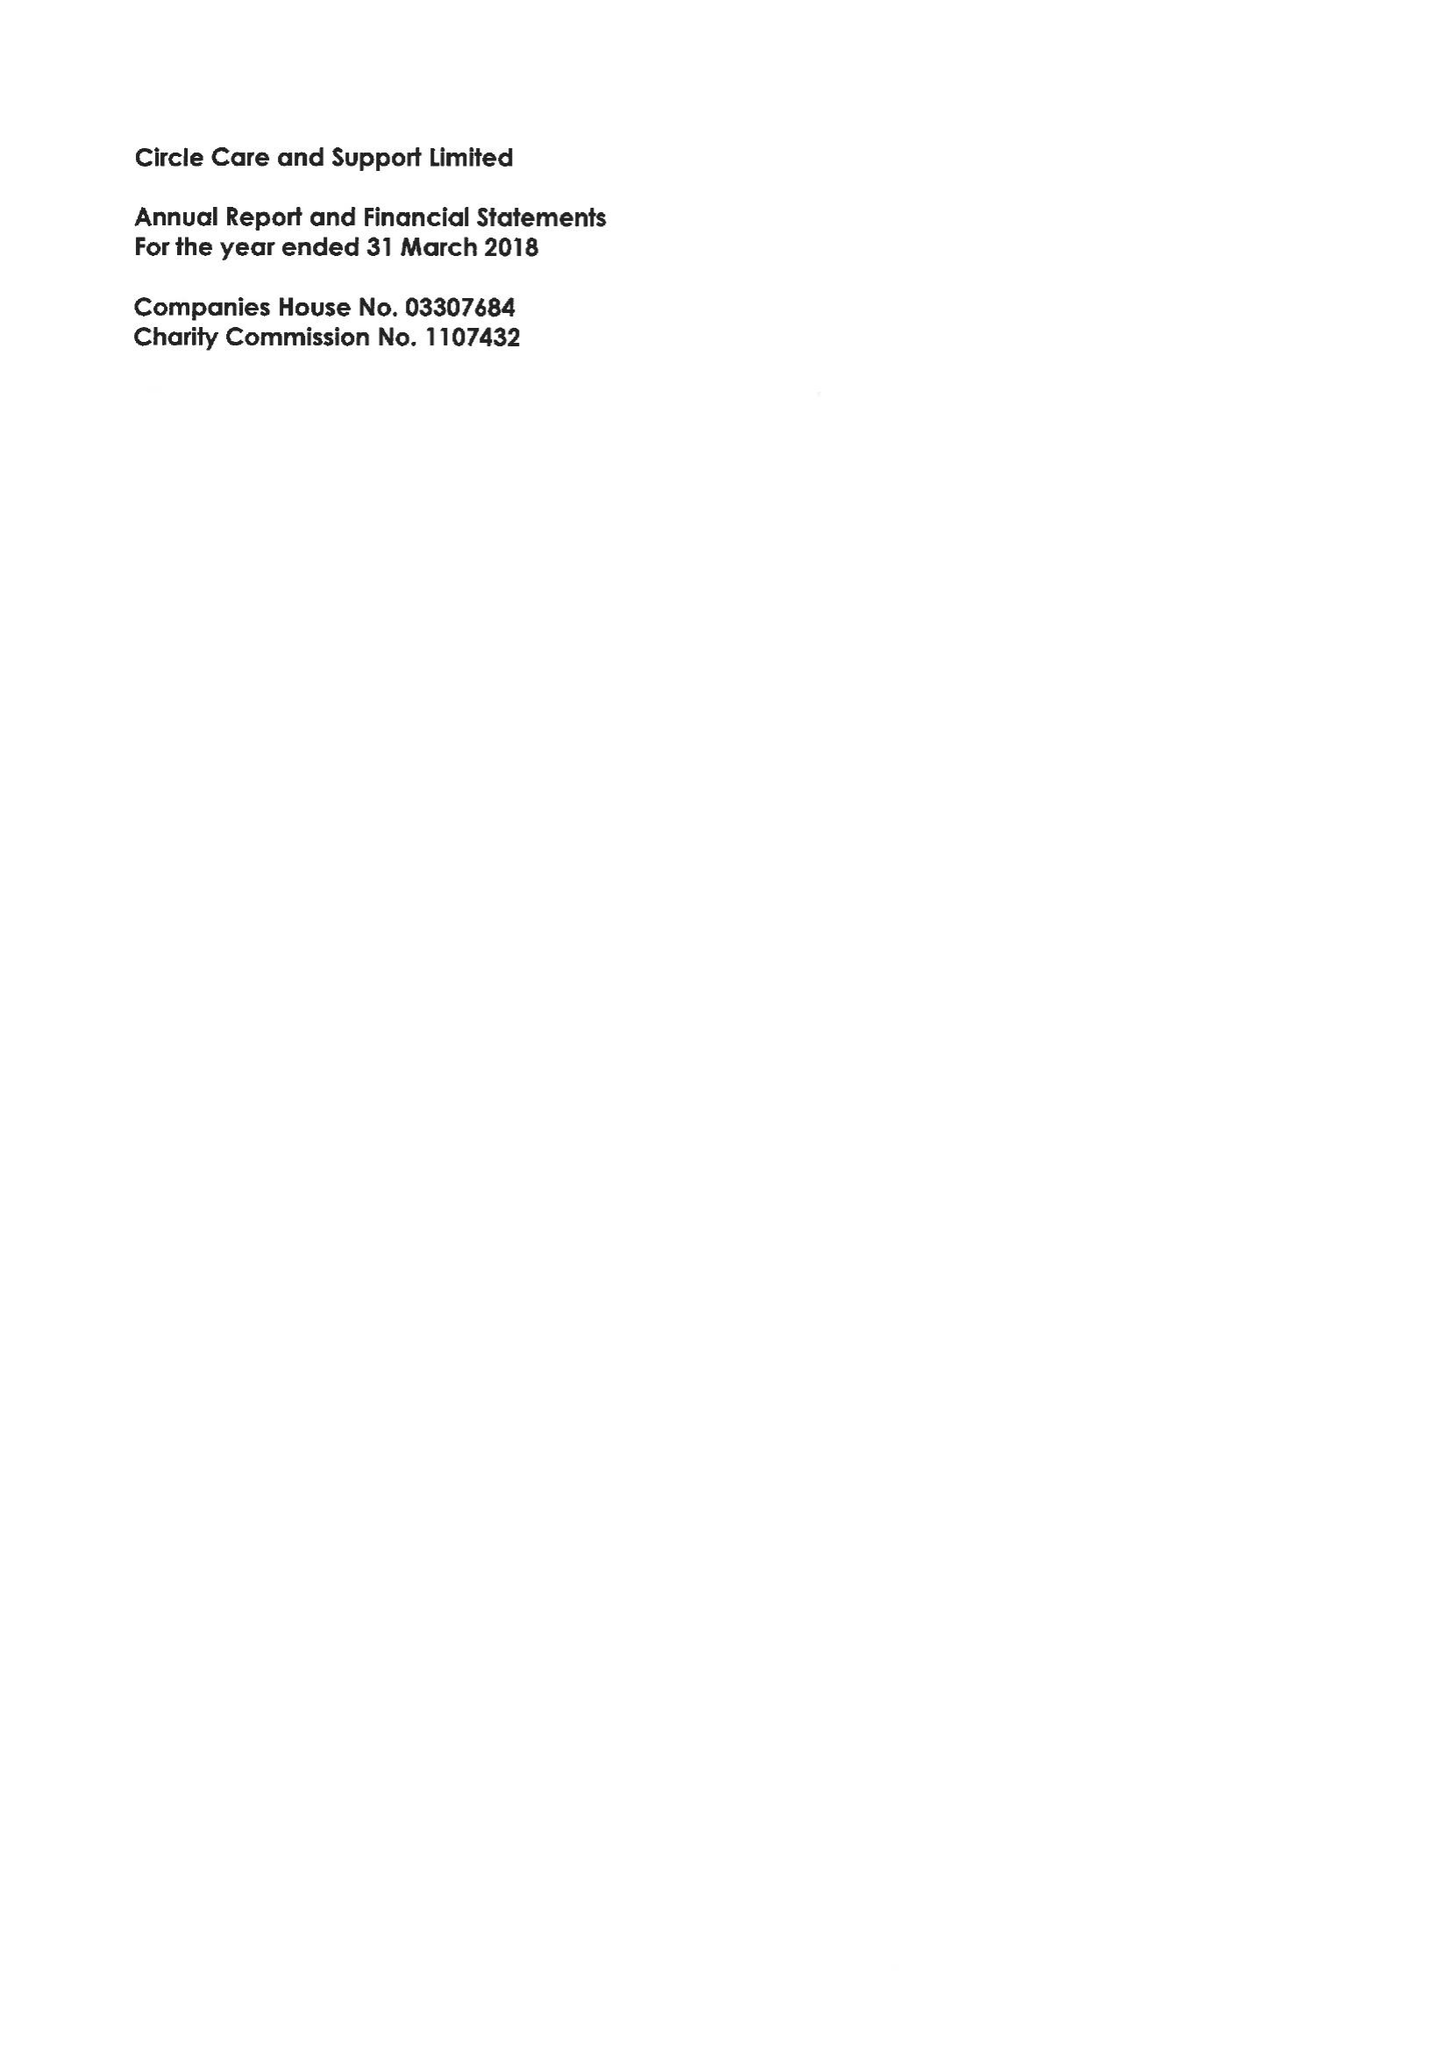What is the value for the charity_number?
Answer the question using a single word or phrase. 1107432 